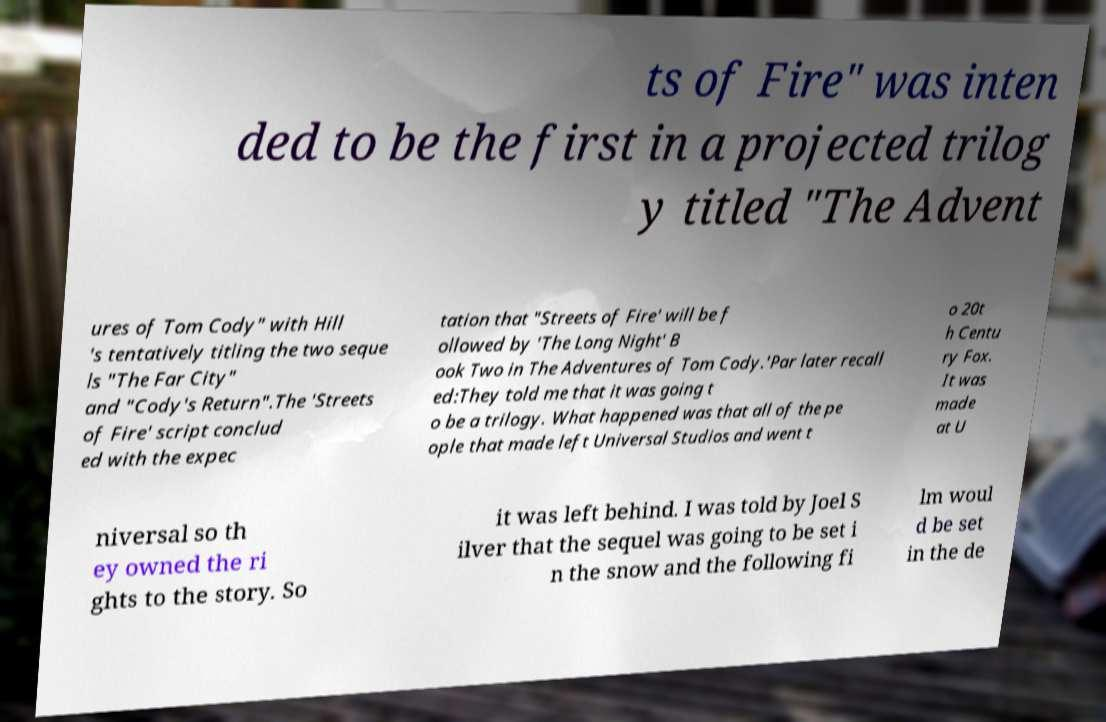For documentation purposes, I need the text within this image transcribed. Could you provide that? ts of Fire" was inten ded to be the first in a projected trilog y titled "The Advent ures of Tom Cody" with Hill 's tentatively titling the two seque ls "The Far City" and "Cody's Return".The 'Streets of Fire' script conclud ed with the expec tation that "Streets of Fire' will be f ollowed by 'The Long Night' B ook Two in The Adventures of Tom Cody.'Par later recall ed:They told me that it was going t o be a trilogy. What happened was that all of the pe ople that made left Universal Studios and went t o 20t h Centu ry Fox. It was made at U niversal so th ey owned the ri ghts to the story. So it was left behind. I was told by Joel S ilver that the sequel was going to be set i n the snow and the following fi lm woul d be set in the de 